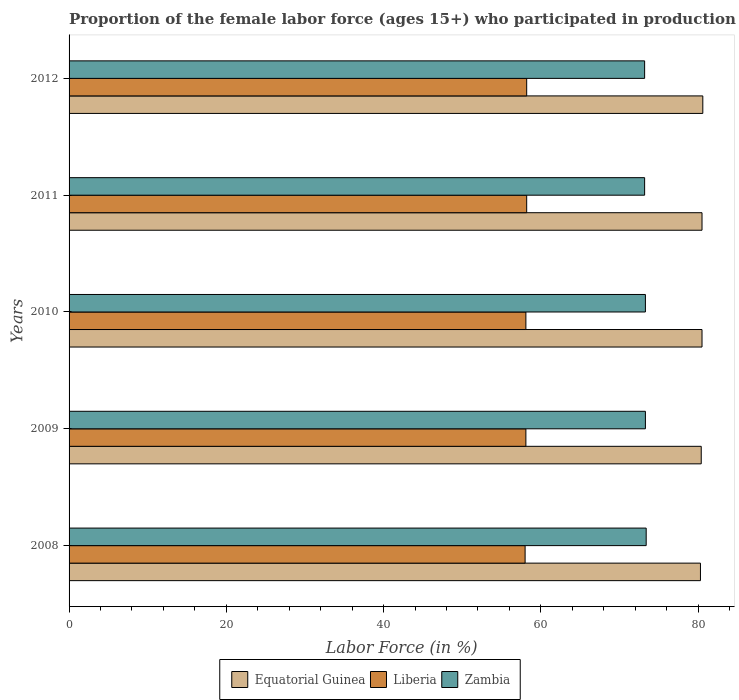Are the number of bars on each tick of the Y-axis equal?
Keep it short and to the point. Yes. How many bars are there on the 3rd tick from the bottom?
Offer a very short reply. 3. What is the label of the 2nd group of bars from the top?
Offer a terse response. 2011. What is the proportion of the female labor force who participated in production in Equatorial Guinea in 2009?
Give a very brief answer. 80.4. Across all years, what is the maximum proportion of the female labor force who participated in production in Liberia?
Keep it short and to the point. 58.2. Across all years, what is the minimum proportion of the female labor force who participated in production in Zambia?
Keep it short and to the point. 73.2. In which year was the proportion of the female labor force who participated in production in Equatorial Guinea minimum?
Your response must be concise. 2008. What is the total proportion of the female labor force who participated in production in Equatorial Guinea in the graph?
Provide a short and direct response. 402.3. What is the difference between the proportion of the female labor force who participated in production in Liberia in 2010 and that in 2011?
Your response must be concise. -0.1. What is the difference between the proportion of the female labor force who participated in production in Liberia in 2010 and the proportion of the female labor force who participated in production in Zambia in 2008?
Offer a terse response. -15.3. What is the average proportion of the female labor force who participated in production in Zambia per year?
Provide a short and direct response. 73.28. In the year 2010, what is the difference between the proportion of the female labor force who participated in production in Equatorial Guinea and proportion of the female labor force who participated in production in Liberia?
Keep it short and to the point. 22.4. What is the ratio of the proportion of the female labor force who participated in production in Zambia in 2008 to that in 2011?
Provide a short and direct response. 1. Is the proportion of the female labor force who participated in production in Liberia in 2010 less than that in 2012?
Your answer should be compact. Yes. What is the difference between the highest and the second highest proportion of the female labor force who participated in production in Equatorial Guinea?
Your answer should be compact. 0.1. What is the difference between the highest and the lowest proportion of the female labor force who participated in production in Equatorial Guinea?
Give a very brief answer. 0.3. In how many years, is the proportion of the female labor force who participated in production in Zambia greater than the average proportion of the female labor force who participated in production in Zambia taken over all years?
Give a very brief answer. 3. Is the sum of the proportion of the female labor force who participated in production in Liberia in 2009 and 2010 greater than the maximum proportion of the female labor force who participated in production in Zambia across all years?
Your response must be concise. Yes. What does the 1st bar from the top in 2010 represents?
Ensure brevity in your answer.  Zambia. What does the 2nd bar from the bottom in 2011 represents?
Ensure brevity in your answer.  Liberia. Are all the bars in the graph horizontal?
Keep it short and to the point. Yes. How many legend labels are there?
Your answer should be compact. 3. What is the title of the graph?
Provide a succinct answer. Proportion of the female labor force (ages 15+) who participated in production. What is the label or title of the X-axis?
Make the answer very short. Labor Force (in %). What is the label or title of the Y-axis?
Your response must be concise. Years. What is the Labor Force (in %) of Equatorial Guinea in 2008?
Your response must be concise. 80.3. What is the Labor Force (in %) in Zambia in 2008?
Ensure brevity in your answer.  73.4. What is the Labor Force (in %) in Equatorial Guinea in 2009?
Offer a very short reply. 80.4. What is the Labor Force (in %) of Liberia in 2009?
Offer a very short reply. 58.1. What is the Labor Force (in %) in Zambia in 2009?
Your answer should be compact. 73.3. What is the Labor Force (in %) of Equatorial Guinea in 2010?
Your answer should be compact. 80.5. What is the Labor Force (in %) of Liberia in 2010?
Your answer should be very brief. 58.1. What is the Labor Force (in %) in Zambia in 2010?
Your answer should be very brief. 73.3. What is the Labor Force (in %) in Equatorial Guinea in 2011?
Offer a terse response. 80.5. What is the Labor Force (in %) of Liberia in 2011?
Provide a short and direct response. 58.2. What is the Labor Force (in %) in Zambia in 2011?
Your response must be concise. 73.2. What is the Labor Force (in %) of Equatorial Guinea in 2012?
Your response must be concise. 80.6. What is the Labor Force (in %) in Liberia in 2012?
Give a very brief answer. 58.2. What is the Labor Force (in %) of Zambia in 2012?
Your response must be concise. 73.2. Across all years, what is the maximum Labor Force (in %) in Equatorial Guinea?
Your response must be concise. 80.6. Across all years, what is the maximum Labor Force (in %) of Liberia?
Your answer should be compact. 58.2. Across all years, what is the maximum Labor Force (in %) of Zambia?
Provide a short and direct response. 73.4. Across all years, what is the minimum Labor Force (in %) in Equatorial Guinea?
Offer a terse response. 80.3. Across all years, what is the minimum Labor Force (in %) of Zambia?
Provide a succinct answer. 73.2. What is the total Labor Force (in %) in Equatorial Guinea in the graph?
Provide a short and direct response. 402.3. What is the total Labor Force (in %) of Liberia in the graph?
Ensure brevity in your answer.  290.6. What is the total Labor Force (in %) of Zambia in the graph?
Your answer should be very brief. 366.4. What is the difference between the Labor Force (in %) in Equatorial Guinea in 2008 and that in 2010?
Make the answer very short. -0.2. What is the difference between the Labor Force (in %) in Liberia in 2008 and that in 2010?
Your response must be concise. -0.1. What is the difference between the Labor Force (in %) of Zambia in 2008 and that in 2010?
Make the answer very short. 0.1. What is the difference between the Labor Force (in %) in Equatorial Guinea in 2008 and that in 2011?
Make the answer very short. -0.2. What is the difference between the Labor Force (in %) in Liberia in 2008 and that in 2011?
Offer a very short reply. -0.2. What is the difference between the Labor Force (in %) in Zambia in 2008 and that in 2011?
Give a very brief answer. 0.2. What is the difference between the Labor Force (in %) of Equatorial Guinea in 2008 and that in 2012?
Ensure brevity in your answer.  -0.3. What is the difference between the Labor Force (in %) of Liberia in 2008 and that in 2012?
Make the answer very short. -0.2. What is the difference between the Labor Force (in %) of Equatorial Guinea in 2009 and that in 2010?
Keep it short and to the point. -0.1. What is the difference between the Labor Force (in %) of Liberia in 2009 and that in 2010?
Your response must be concise. 0. What is the difference between the Labor Force (in %) in Equatorial Guinea in 2009 and that in 2011?
Ensure brevity in your answer.  -0.1. What is the difference between the Labor Force (in %) of Zambia in 2009 and that in 2011?
Provide a succinct answer. 0.1. What is the difference between the Labor Force (in %) of Equatorial Guinea in 2009 and that in 2012?
Your answer should be very brief. -0.2. What is the difference between the Labor Force (in %) of Liberia in 2009 and that in 2012?
Ensure brevity in your answer.  -0.1. What is the difference between the Labor Force (in %) of Zambia in 2009 and that in 2012?
Offer a very short reply. 0.1. What is the difference between the Labor Force (in %) in Liberia in 2010 and that in 2011?
Offer a very short reply. -0.1. What is the difference between the Labor Force (in %) of Zambia in 2010 and that in 2011?
Your response must be concise. 0.1. What is the difference between the Labor Force (in %) of Liberia in 2010 and that in 2012?
Make the answer very short. -0.1. What is the difference between the Labor Force (in %) in Zambia in 2010 and that in 2012?
Your answer should be very brief. 0.1. What is the difference between the Labor Force (in %) in Equatorial Guinea in 2011 and that in 2012?
Provide a succinct answer. -0.1. What is the difference between the Labor Force (in %) in Equatorial Guinea in 2008 and the Labor Force (in %) in Liberia in 2009?
Your response must be concise. 22.2. What is the difference between the Labor Force (in %) of Liberia in 2008 and the Labor Force (in %) of Zambia in 2009?
Offer a very short reply. -15.3. What is the difference between the Labor Force (in %) in Equatorial Guinea in 2008 and the Labor Force (in %) in Zambia in 2010?
Give a very brief answer. 7. What is the difference between the Labor Force (in %) in Liberia in 2008 and the Labor Force (in %) in Zambia in 2010?
Ensure brevity in your answer.  -15.3. What is the difference between the Labor Force (in %) of Equatorial Guinea in 2008 and the Labor Force (in %) of Liberia in 2011?
Provide a succinct answer. 22.1. What is the difference between the Labor Force (in %) of Equatorial Guinea in 2008 and the Labor Force (in %) of Zambia in 2011?
Provide a succinct answer. 7.1. What is the difference between the Labor Force (in %) in Liberia in 2008 and the Labor Force (in %) in Zambia in 2011?
Your answer should be compact. -15.2. What is the difference between the Labor Force (in %) of Equatorial Guinea in 2008 and the Labor Force (in %) of Liberia in 2012?
Provide a succinct answer. 22.1. What is the difference between the Labor Force (in %) of Liberia in 2008 and the Labor Force (in %) of Zambia in 2012?
Provide a succinct answer. -15.2. What is the difference between the Labor Force (in %) in Equatorial Guinea in 2009 and the Labor Force (in %) in Liberia in 2010?
Your answer should be very brief. 22.3. What is the difference between the Labor Force (in %) in Liberia in 2009 and the Labor Force (in %) in Zambia in 2010?
Offer a terse response. -15.2. What is the difference between the Labor Force (in %) of Liberia in 2009 and the Labor Force (in %) of Zambia in 2011?
Ensure brevity in your answer.  -15.1. What is the difference between the Labor Force (in %) of Liberia in 2009 and the Labor Force (in %) of Zambia in 2012?
Provide a short and direct response. -15.1. What is the difference between the Labor Force (in %) in Equatorial Guinea in 2010 and the Labor Force (in %) in Liberia in 2011?
Your answer should be compact. 22.3. What is the difference between the Labor Force (in %) in Equatorial Guinea in 2010 and the Labor Force (in %) in Zambia in 2011?
Ensure brevity in your answer.  7.3. What is the difference between the Labor Force (in %) in Liberia in 2010 and the Labor Force (in %) in Zambia in 2011?
Ensure brevity in your answer.  -15.1. What is the difference between the Labor Force (in %) of Equatorial Guinea in 2010 and the Labor Force (in %) of Liberia in 2012?
Provide a short and direct response. 22.3. What is the difference between the Labor Force (in %) in Liberia in 2010 and the Labor Force (in %) in Zambia in 2012?
Your response must be concise. -15.1. What is the difference between the Labor Force (in %) of Equatorial Guinea in 2011 and the Labor Force (in %) of Liberia in 2012?
Ensure brevity in your answer.  22.3. What is the difference between the Labor Force (in %) in Equatorial Guinea in 2011 and the Labor Force (in %) in Zambia in 2012?
Keep it short and to the point. 7.3. What is the average Labor Force (in %) in Equatorial Guinea per year?
Your answer should be compact. 80.46. What is the average Labor Force (in %) in Liberia per year?
Offer a very short reply. 58.12. What is the average Labor Force (in %) of Zambia per year?
Give a very brief answer. 73.28. In the year 2008, what is the difference between the Labor Force (in %) of Equatorial Guinea and Labor Force (in %) of Liberia?
Ensure brevity in your answer.  22.3. In the year 2008, what is the difference between the Labor Force (in %) in Equatorial Guinea and Labor Force (in %) in Zambia?
Make the answer very short. 6.9. In the year 2008, what is the difference between the Labor Force (in %) in Liberia and Labor Force (in %) in Zambia?
Ensure brevity in your answer.  -15.4. In the year 2009, what is the difference between the Labor Force (in %) of Equatorial Guinea and Labor Force (in %) of Liberia?
Your answer should be very brief. 22.3. In the year 2009, what is the difference between the Labor Force (in %) of Equatorial Guinea and Labor Force (in %) of Zambia?
Your response must be concise. 7.1. In the year 2009, what is the difference between the Labor Force (in %) in Liberia and Labor Force (in %) in Zambia?
Your answer should be very brief. -15.2. In the year 2010, what is the difference between the Labor Force (in %) of Equatorial Guinea and Labor Force (in %) of Liberia?
Your answer should be very brief. 22.4. In the year 2010, what is the difference between the Labor Force (in %) in Liberia and Labor Force (in %) in Zambia?
Your response must be concise. -15.2. In the year 2011, what is the difference between the Labor Force (in %) of Equatorial Guinea and Labor Force (in %) of Liberia?
Your answer should be compact. 22.3. In the year 2011, what is the difference between the Labor Force (in %) in Liberia and Labor Force (in %) in Zambia?
Make the answer very short. -15. In the year 2012, what is the difference between the Labor Force (in %) of Equatorial Guinea and Labor Force (in %) of Liberia?
Keep it short and to the point. 22.4. In the year 2012, what is the difference between the Labor Force (in %) of Equatorial Guinea and Labor Force (in %) of Zambia?
Your answer should be compact. 7.4. In the year 2012, what is the difference between the Labor Force (in %) in Liberia and Labor Force (in %) in Zambia?
Provide a short and direct response. -15. What is the ratio of the Labor Force (in %) of Equatorial Guinea in 2008 to that in 2009?
Offer a very short reply. 1. What is the ratio of the Labor Force (in %) in Liberia in 2008 to that in 2009?
Provide a short and direct response. 1. What is the ratio of the Labor Force (in %) in Equatorial Guinea in 2008 to that in 2010?
Provide a succinct answer. 1. What is the ratio of the Labor Force (in %) in Equatorial Guinea in 2008 to that in 2011?
Make the answer very short. 1. What is the ratio of the Labor Force (in %) in Liberia in 2008 to that in 2011?
Your answer should be compact. 1. What is the ratio of the Labor Force (in %) in Zambia in 2008 to that in 2011?
Provide a succinct answer. 1. What is the ratio of the Labor Force (in %) of Zambia in 2008 to that in 2012?
Your answer should be very brief. 1. What is the ratio of the Labor Force (in %) in Equatorial Guinea in 2009 to that in 2010?
Your answer should be compact. 1. What is the ratio of the Labor Force (in %) of Zambia in 2009 to that in 2010?
Make the answer very short. 1. What is the ratio of the Labor Force (in %) in Equatorial Guinea in 2009 to that in 2011?
Make the answer very short. 1. What is the ratio of the Labor Force (in %) in Liberia in 2009 to that in 2012?
Keep it short and to the point. 1. What is the ratio of the Labor Force (in %) of Zambia in 2009 to that in 2012?
Your response must be concise. 1. What is the ratio of the Labor Force (in %) of Equatorial Guinea in 2010 to that in 2012?
Provide a short and direct response. 1. What is the ratio of the Labor Force (in %) of Liberia in 2010 to that in 2012?
Your answer should be very brief. 1. What is the ratio of the Labor Force (in %) of Zambia in 2010 to that in 2012?
Offer a terse response. 1. What is the difference between the highest and the second highest Labor Force (in %) of Liberia?
Your answer should be compact. 0. What is the difference between the highest and the lowest Labor Force (in %) of Liberia?
Give a very brief answer. 0.2. 